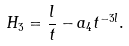Convert formula to latex. <formula><loc_0><loc_0><loc_500><loc_500>H _ { 3 } = \frac { l } { t } - a _ { 4 } t ^ { - 3 l } .</formula> 